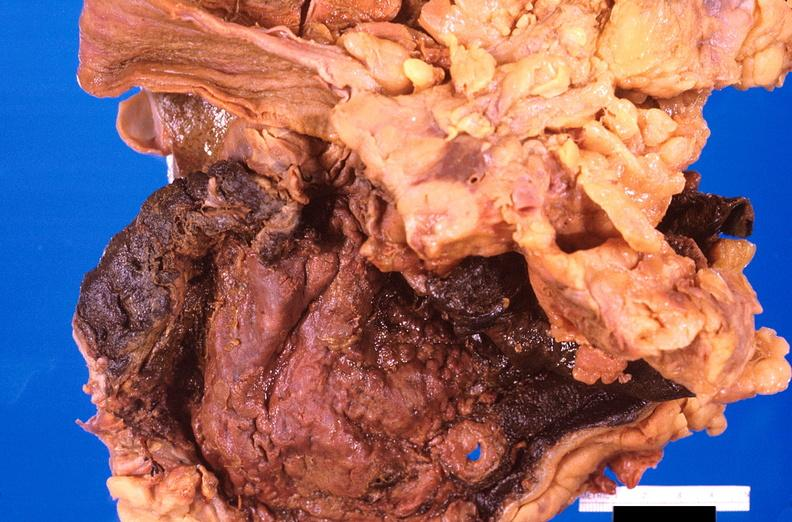what ingested as suicide attempt?
Answer the question using a single word or phrase. Stomach, necrotizing esophagitis and gastritis, sulfuric acid 